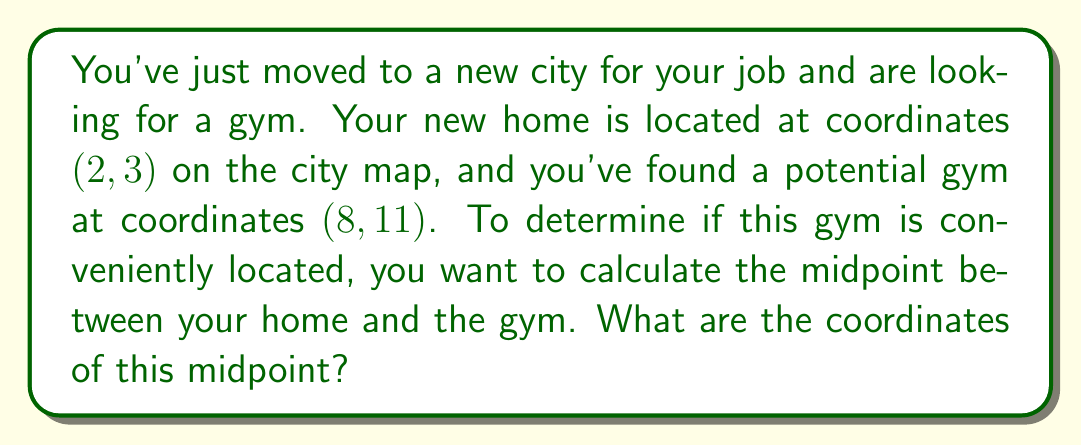Teach me how to tackle this problem. To find the midpoint between two points, we use the midpoint formula:

$$ \text{Midpoint} = \left(\frac{x_1 + x_2}{2}, \frac{y_1 + y_2}{2}\right) $$

Where $(x_1, y_1)$ are the coordinates of the first point (your home) and $(x_2, y_2)$ are the coordinates of the second point (the gym).

Given:
- Your home coordinates: $(2, 3)$
- Gym coordinates: $(8, 11)$

Let's substitute these values into the midpoint formula:

$$ \text{Midpoint} = \left(\frac{2 + 8}{2}, \frac{3 + 11}{2}\right) $$

Now, let's calculate each coordinate:

For the x-coordinate:
$$ \frac{2 + 8}{2} = \frac{10}{2} = 5 $$

For the y-coordinate:
$$ \frac{3 + 11}{2} = \frac{14}{2} = 7 $$

Therefore, the midpoint coordinates are $(5, 7)$.

[asy]
unitsize(1cm);
defaultpen(fontsize(10pt));

// Draw axes
draw((-1,0)--(10,0), arrow=Arrow(TeXHead));
draw((0,-1)--(0,12), arrow=Arrow(TeXHead));

// Label axes
label("x", (10,0), E);
label("y", (0,12), N);

// Plot points
dot((2,3), red);
dot((8,11), blue);
dot((5,7), green);

// Label points
label("Home (2,3)", (2,3), SW, red);
label("Gym (8,11)", (8,11), NE, blue);
label("Midpoint (5,7)", (5,7), SE, green);

// Draw line connecting points
draw((2,3)--(8,11), dashed);
[/asy]
Answer: The coordinates of the midpoint between your home and the potential gym location are $(5, 7)$. 